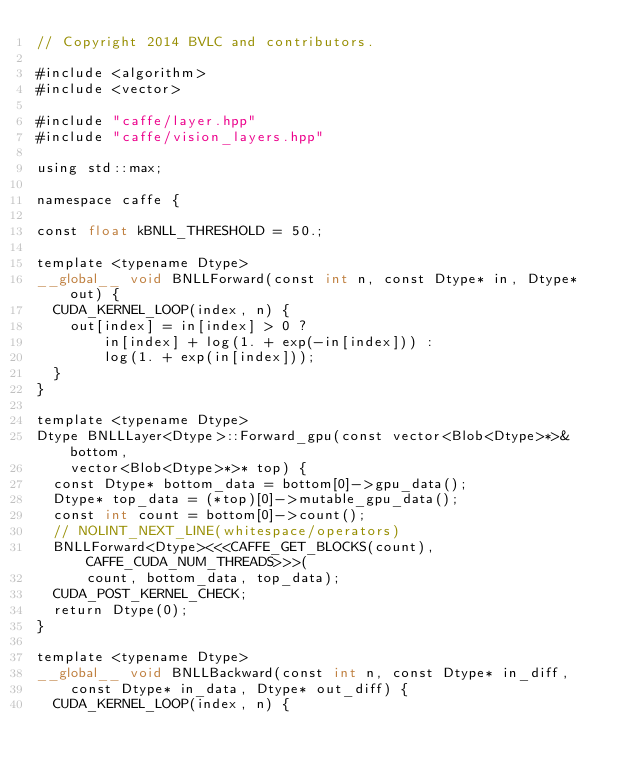Convert code to text. <code><loc_0><loc_0><loc_500><loc_500><_Cuda_>// Copyright 2014 BVLC and contributors.

#include <algorithm>
#include <vector>

#include "caffe/layer.hpp"
#include "caffe/vision_layers.hpp"

using std::max;

namespace caffe {

const float kBNLL_THRESHOLD = 50.;

template <typename Dtype>
__global__ void BNLLForward(const int n, const Dtype* in, Dtype* out) {
  CUDA_KERNEL_LOOP(index, n) {
    out[index] = in[index] > 0 ?
        in[index] + log(1. + exp(-in[index])) :
        log(1. + exp(in[index]));
  }
}

template <typename Dtype>
Dtype BNLLLayer<Dtype>::Forward_gpu(const vector<Blob<Dtype>*>& bottom,
    vector<Blob<Dtype>*>* top) {
  const Dtype* bottom_data = bottom[0]->gpu_data();
  Dtype* top_data = (*top)[0]->mutable_gpu_data();
  const int count = bottom[0]->count();
  // NOLINT_NEXT_LINE(whitespace/operators)
  BNLLForward<Dtype><<<CAFFE_GET_BLOCKS(count), CAFFE_CUDA_NUM_THREADS>>>(
      count, bottom_data, top_data);
  CUDA_POST_KERNEL_CHECK;
  return Dtype(0);
}

template <typename Dtype>
__global__ void BNLLBackward(const int n, const Dtype* in_diff,
    const Dtype* in_data, Dtype* out_diff) {
  CUDA_KERNEL_LOOP(index, n) {</code> 